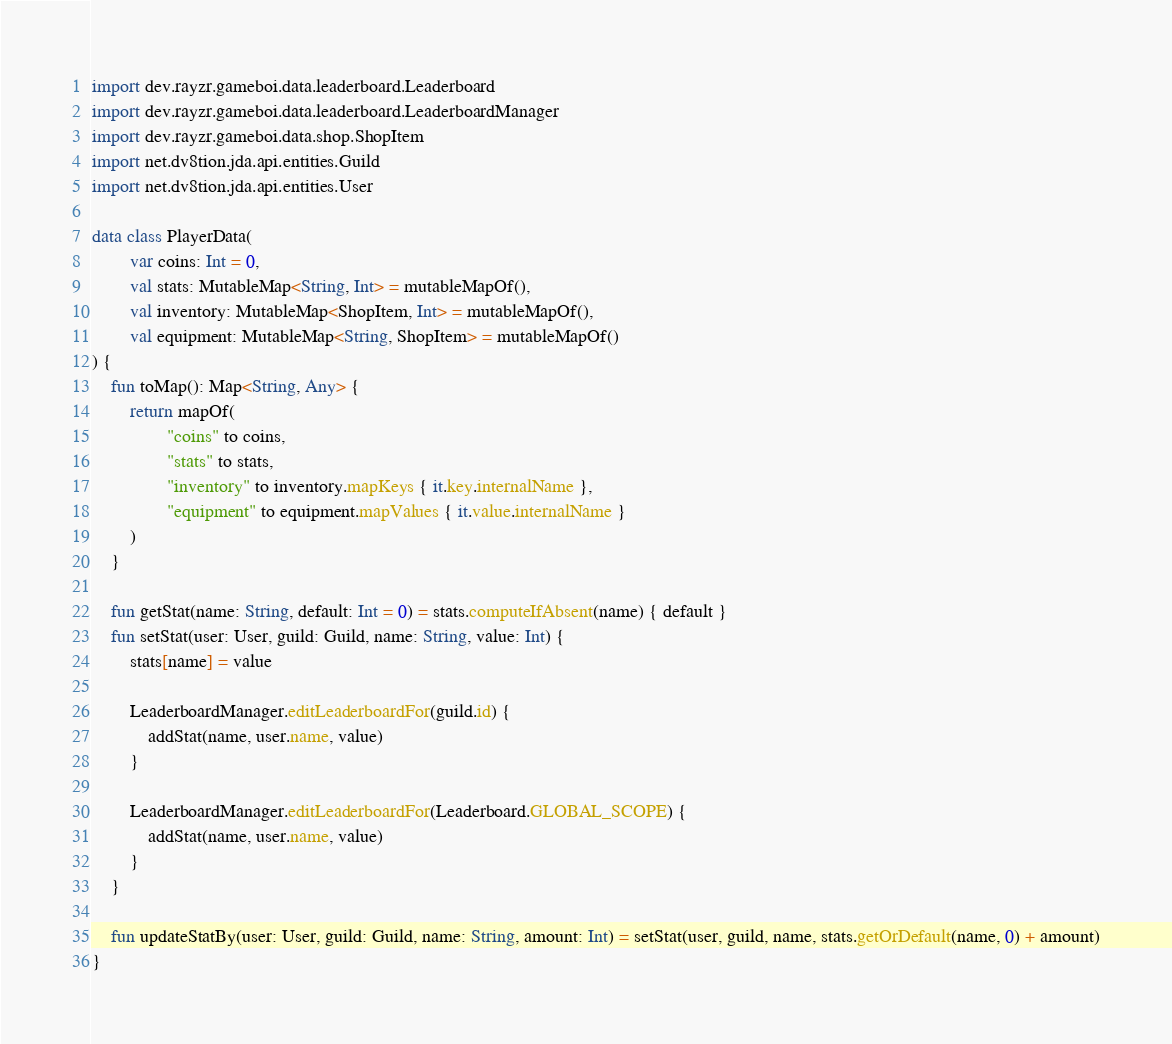Convert code to text. <code><loc_0><loc_0><loc_500><loc_500><_Kotlin_>import dev.rayzr.gameboi.data.leaderboard.Leaderboard
import dev.rayzr.gameboi.data.leaderboard.LeaderboardManager
import dev.rayzr.gameboi.data.shop.ShopItem
import net.dv8tion.jda.api.entities.Guild
import net.dv8tion.jda.api.entities.User

data class PlayerData(
        var coins: Int = 0,
        val stats: MutableMap<String, Int> = mutableMapOf(),
        val inventory: MutableMap<ShopItem, Int> = mutableMapOf(),
        val equipment: MutableMap<String, ShopItem> = mutableMapOf()
) {
    fun toMap(): Map<String, Any> {
        return mapOf(
                "coins" to coins,
                "stats" to stats,
                "inventory" to inventory.mapKeys { it.key.internalName },
                "equipment" to equipment.mapValues { it.value.internalName }
        )
    }

    fun getStat(name: String, default: Int = 0) = stats.computeIfAbsent(name) { default }
    fun setStat(user: User, guild: Guild, name: String, value: Int) {
        stats[name] = value

        LeaderboardManager.editLeaderboardFor(guild.id) {
            addStat(name, user.name, value)
        }

        LeaderboardManager.editLeaderboardFor(Leaderboard.GLOBAL_SCOPE) {
            addStat(name, user.name, value)
        }
    }

    fun updateStatBy(user: User, guild: Guild, name: String, amount: Int) = setStat(user, guild, name, stats.getOrDefault(name, 0) + amount)
}
</code> 